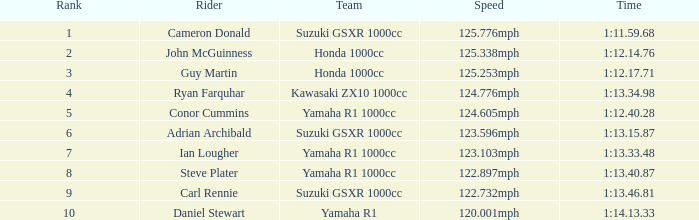4 5.0. 